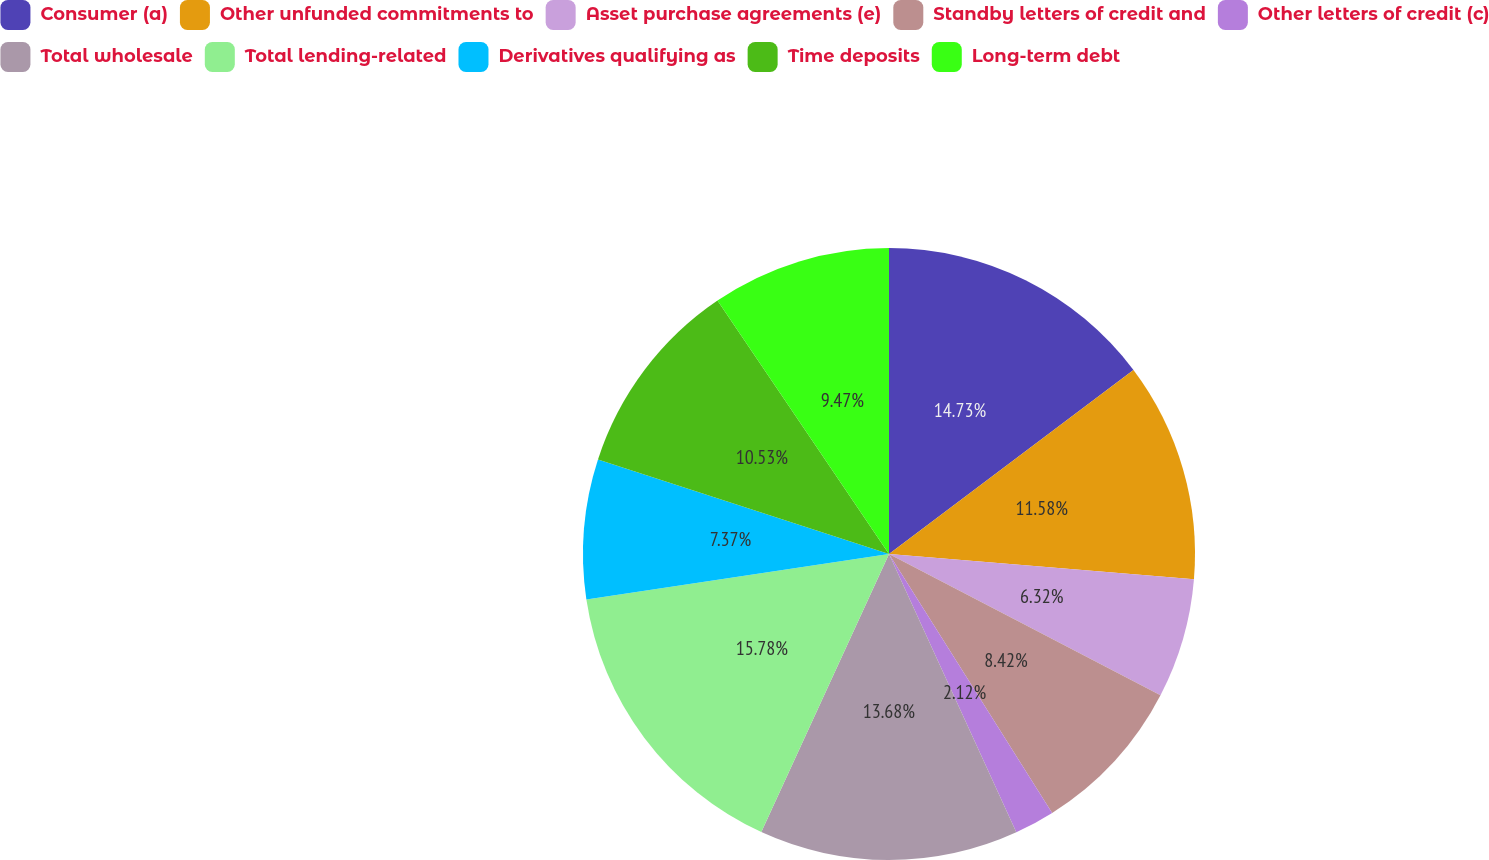<chart> <loc_0><loc_0><loc_500><loc_500><pie_chart><fcel>Consumer (a)<fcel>Other unfunded commitments to<fcel>Asset purchase agreements (e)<fcel>Standby letters of credit and<fcel>Other letters of credit (c)<fcel>Total wholesale<fcel>Total lending-related<fcel>Derivatives qualifying as<fcel>Time deposits<fcel>Long-term debt<nl><fcel>14.73%<fcel>11.58%<fcel>6.32%<fcel>8.42%<fcel>2.12%<fcel>13.68%<fcel>15.78%<fcel>7.37%<fcel>10.53%<fcel>9.47%<nl></chart> 